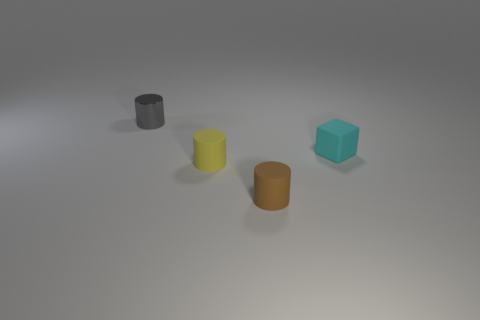Does the cylinder that is on the right side of the yellow object have the same size as the tiny cyan object?
Your answer should be very brief. Yes. The cyan thing is what shape?
Provide a short and direct response. Cube. Do the thing on the right side of the tiny brown rubber cylinder and the yellow object have the same material?
Make the answer very short. Yes. Is there a small thing that has the same color as the small metal cylinder?
Keep it short and to the point. No. There is a tiny thing behind the small cyan cube; is its shape the same as the tiny object right of the brown cylinder?
Ensure brevity in your answer.  No. Is there a cyan object that has the same material as the tiny gray cylinder?
Your answer should be compact. No. How many yellow objects are either spheres or tiny things?
Your response must be concise. 1. How big is the cylinder that is both behind the brown rubber object and in front of the metal cylinder?
Your answer should be very brief. Small. Is the number of cyan cubes that are left of the gray metallic thing greater than the number of tiny blue cylinders?
Keep it short and to the point. No. What number of blocks are either small yellow rubber things or tiny gray metallic objects?
Keep it short and to the point. 0. 